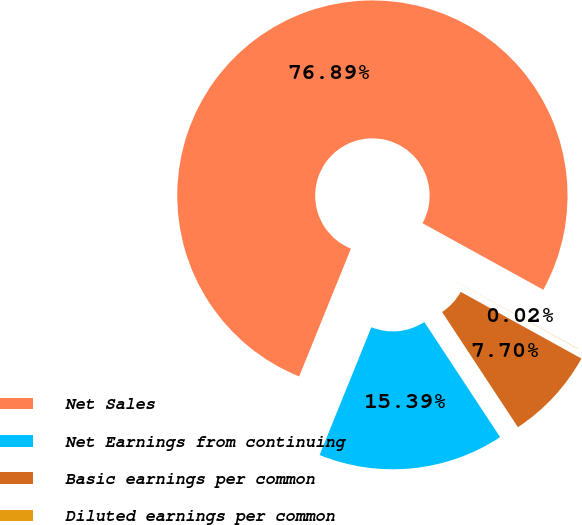Convert chart to OTSL. <chart><loc_0><loc_0><loc_500><loc_500><pie_chart><fcel>Net Sales<fcel>Net Earnings from continuing<fcel>Basic earnings per common<fcel>Diluted earnings per common<nl><fcel>76.89%<fcel>15.39%<fcel>7.7%<fcel>0.02%<nl></chart> 